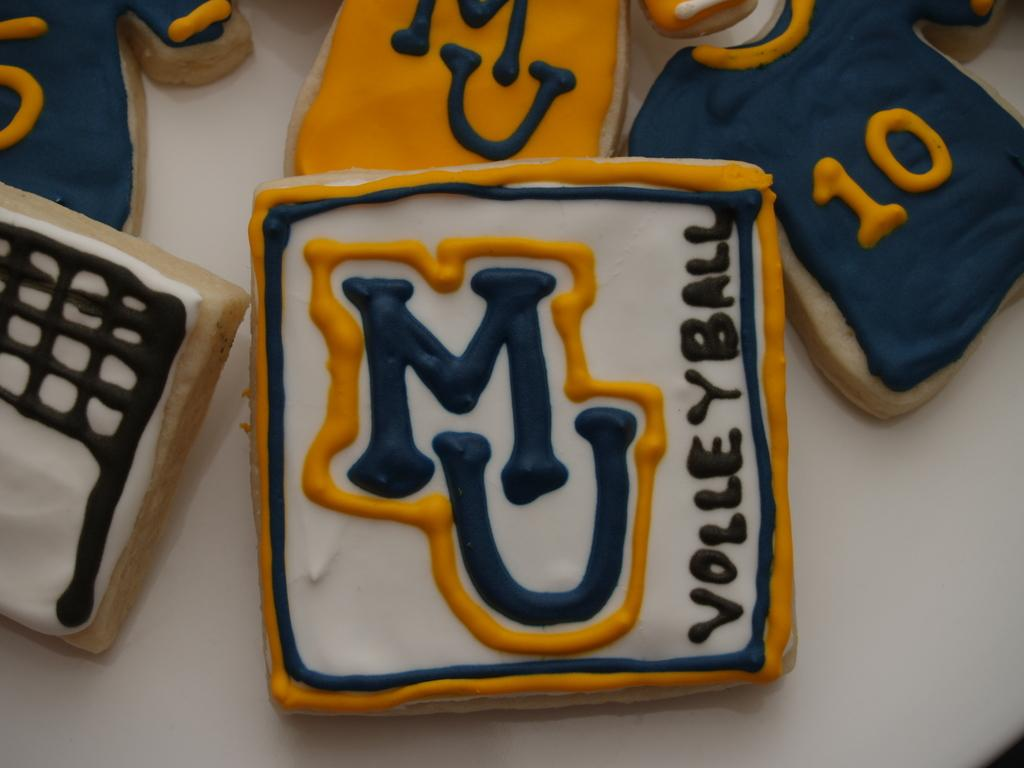<image>
Offer a succinct explanation of the picture presented. Little sweets with the "MU" sort of volleyball logo, an organization of some sort 